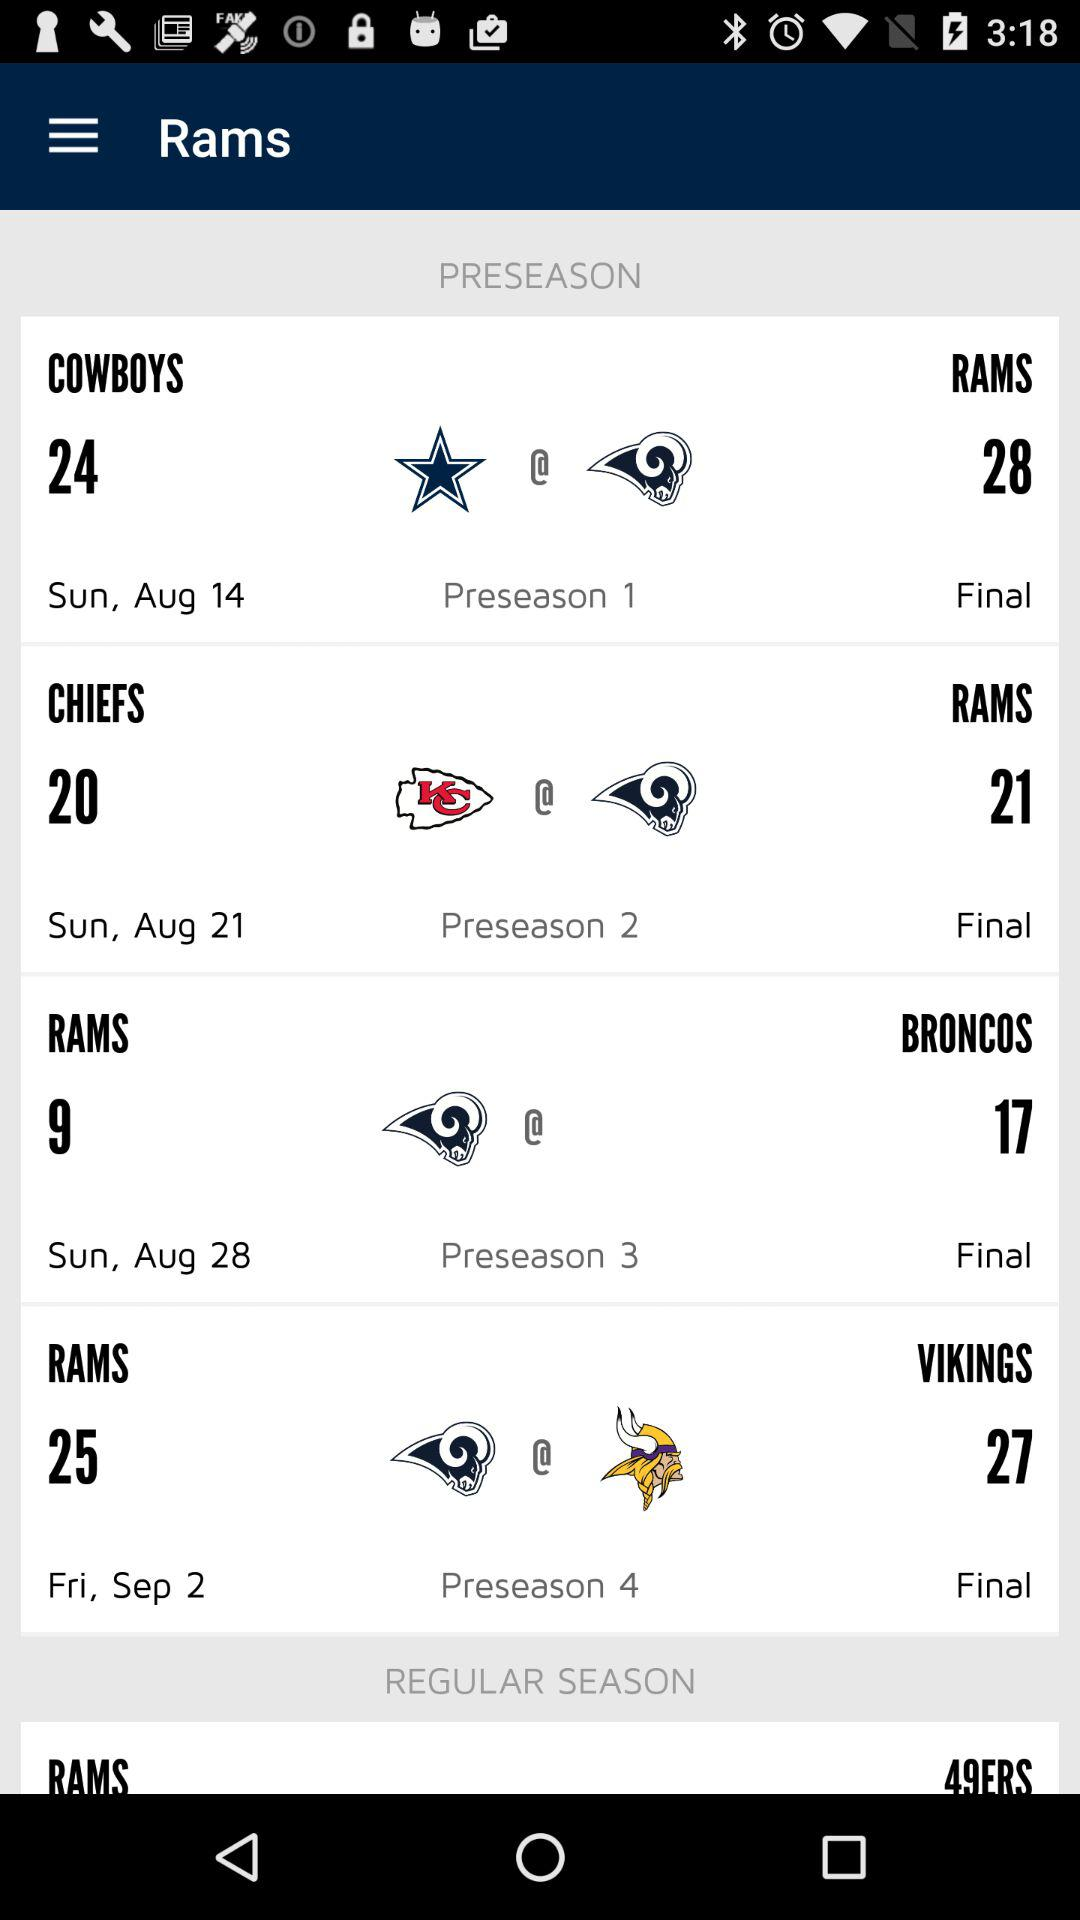What is the date of the last preseason game?
Answer the question using a single word or phrase. Fri, Sep 2 